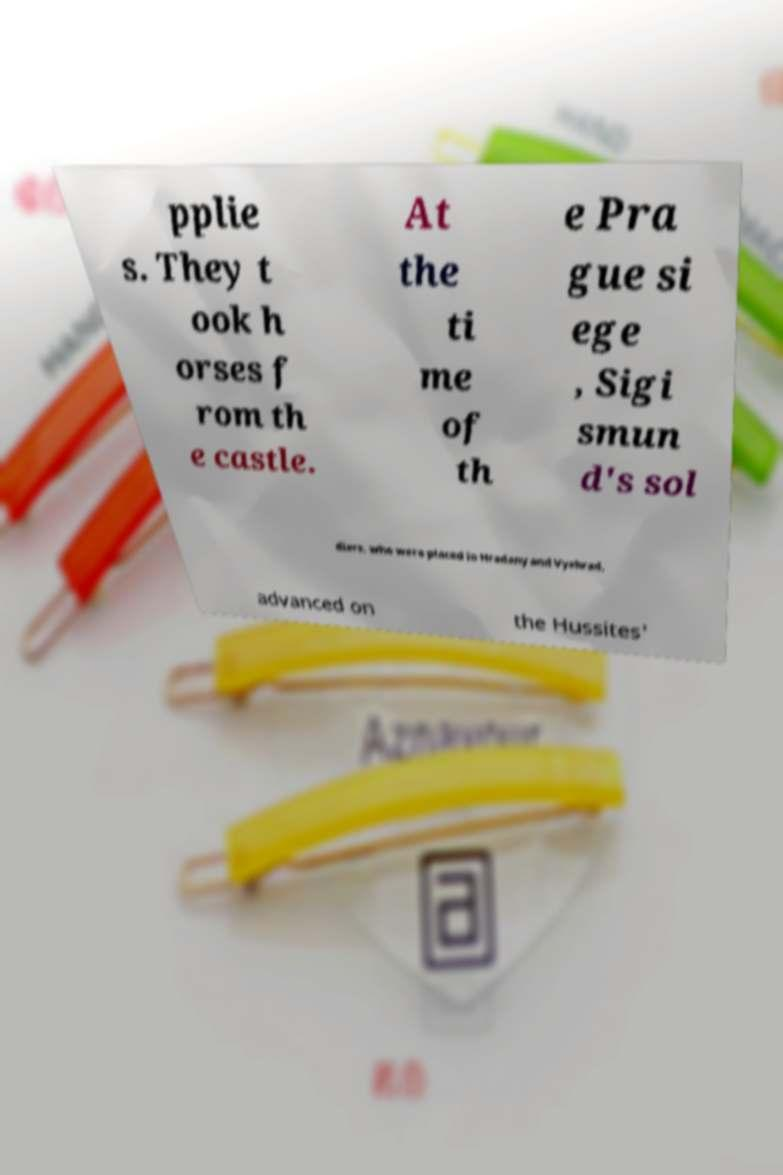Could you extract and type out the text from this image? pplie s. They t ook h orses f rom th e castle. At the ti me of th e Pra gue si ege , Sigi smun d's sol diers, who were placed in Hradany and Vyehrad, advanced on the Hussites' 